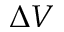<formula> <loc_0><loc_0><loc_500><loc_500>\Delta V</formula> 